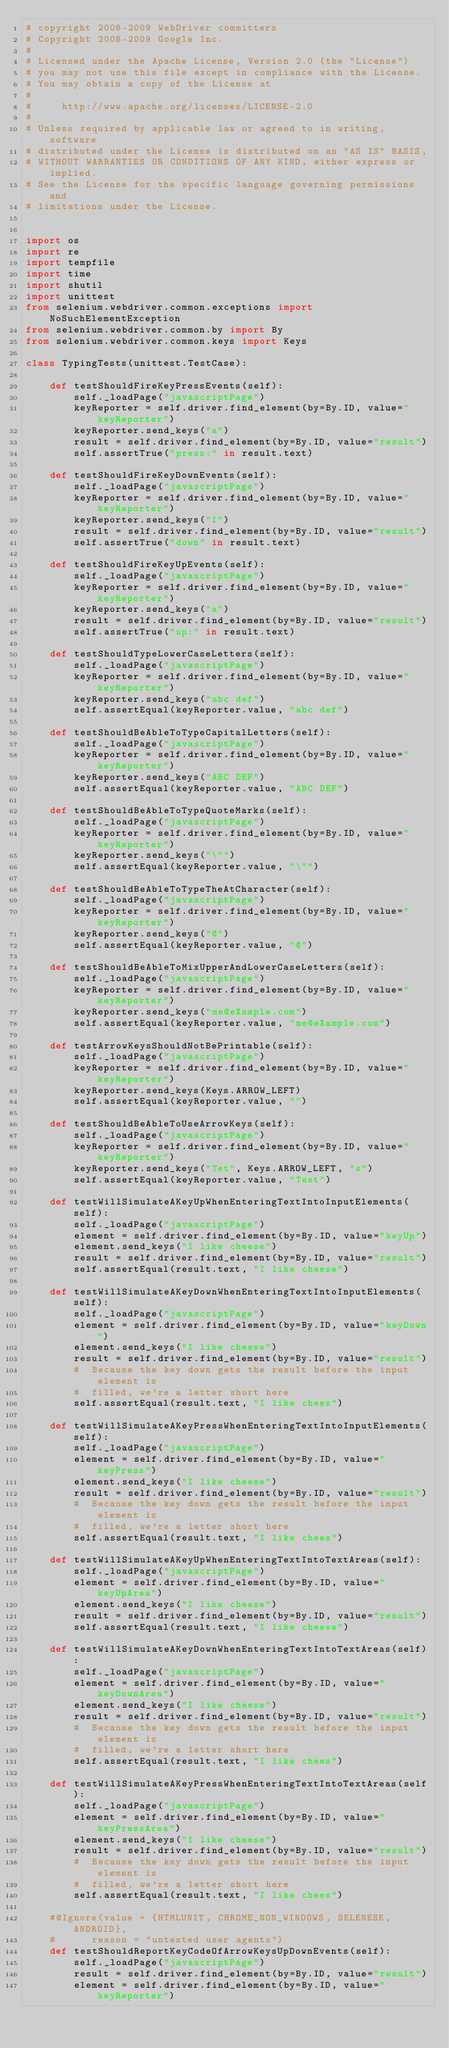<code> <loc_0><loc_0><loc_500><loc_500><_Python_># copyright 2008-2009 WebDriver committers
# Copyright 2008-2009 Google Inc.
#
# Licensed under the Apache License, Version 2.0 (the "License")
# you may not use this file except in compliance with the License.
# You may obtain a copy of the License at
#
#     http://www.apache.org/licenses/LICENSE-2.0
#
# Unless required by applicable law or agreed to in writing, software
# distributed under the License is distributed on an "AS IS" BASIS,
# WITHOUT WARRANTIES OR CONDITIONS OF ANY KIND, either express or implied.
# See the License for the specific language governing permissions and
# limitations under the License.


import os
import re
import tempfile
import time
import shutil
import unittest
from selenium.webdriver.common.exceptions import NoSuchElementException
from selenium.webdriver.common.by import By
from selenium.webdriver.common.keys import Keys

class TypingTests(unittest.TestCase):
  
    def testShouldFireKeyPressEvents(self):
        self._loadPage("javascriptPage")
        keyReporter = self.driver.find_element(by=By.ID, value="keyReporter")
        keyReporter.send_keys("a")
        result = self.driver.find_element(by=By.ID, value="result")
        self.assertTrue("press:" in result.text)

    def testShouldFireKeyDownEvents(self):
        self._loadPage("javascriptPage")
        keyReporter = self.driver.find_element(by=By.ID, value="keyReporter")
        keyReporter.send_keys("I")
        result = self.driver.find_element(by=By.ID, value="result")
        self.assertTrue("down" in result.text)

    def testShouldFireKeyUpEvents(self):
        self._loadPage("javascriptPage")
        keyReporter = self.driver.find_element(by=By.ID, value="keyReporter")
        keyReporter.send_keys("a")
        result = self.driver.find_element(by=By.ID, value="result")
        self.assertTrue("up:" in result.text)

    def testShouldTypeLowerCaseLetters(self):
        self._loadPage("javascriptPage")
        keyReporter = self.driver.find_element(by=By.ID, value="keyReporter")
        keyReporter.send_keys("abc def")
        self.assertEqual(keyReporter.value, "abc def")
    
    def testShouldBeAbleToTypeCapitalLetters(self):
        self._loadPage("javascriptPage")
        keyReporter = self.driver.find_element(by=By.ID, value="keyReporter")
        keyReporter.send_keys("ABC DEF")
        self.assertEqual(keyReporter.value, "ABC DEF")
    
    def testShouldBeAbleToTypeQuoteMarks(self):
        self._loadPage("javascriptPage")
        keyReporter = self.driver.find_element(by=By.ID, value="keyReporter")
        keyReporter.send_keys("\"")
        self.assertEqual(keyReporter.value, "\"")
    
    def testShouldBeAbleToTypeTheAtCharacter(self):
        self._loadPage("javascriptPage")
        keyReporter = self.driver.find_element(by=By.ID, value="keyReporter")
        keyReporter.send_keys("@")
        self.assertEqual(keyReporter.value, "@")
    
    def testShouldBeAbleToMixUpperAndLowerCaseLetters(self):
        self._loadPage("javascriptPage")
        keyReporter = self.driver.find_element(by=By.ID, value="keyReporter")
        keyReporter.send_keys("me@eXample.com")
        self.assertEqual(keyReporter.value, "me@eXample.com")

    def testArrowKeysShouldNotBePrintable(self):
        self._loadPage("javascriptPage")
        keyReporter = self.driver.find_element(by=By.ID, value="keyReporter")
        keyReporter.send_keys(Keys.ARROW_LEFT)
        self.assertEqual(keyReporter.value, "")

    def testShouldBeAbleToUseArrowKeys(self):
        self._loadPage("javascriptPage")
        keyReporter = self.driver.find_element(by=By.ID, value="keyReporter")
        keyReporter.send_keys("Tet", Keys.ARROW_LEFT, "s")
        self.assertEqual(keyReporter.value, "Test")

    def testWillSimulateAKeyUpWhenEnteringTextIntoInputElements(self):
        self._loadPage("javascriptPage")
        element = self.driver.find_element(by=By.ID, value="keyUp")
        element.send_keys("I like cheese")
        result = self.driver.find_element(by=By.ID, value="result")
        self.assertEqual(result.text, "I like cheese")

    def testWillSimulateAKeyDownWhenEnteringTextIntoInputElements(self):
        self._loadPage("javascriptPage")
        element = self.driver.find_element(by=By.ID, value="keyDown")
        element.send_keys("I like cheese")
        result = self.driver.find_element(by=By.ID, value="result")
        #  Because the key down gets the result before the input element is
        #  filled, we're a letter short here
        self.assertEqual(result.text, "I like chees")

    def testWillSimulateAKeyPressWhenEnteringTextIntoInputElements(self):
        self._loadPage("javascriptPage")
        element = self.driver.find_element(by=By.ID, value="keyPress")
        element.send_keys("I like cheese")
        result = self.driver.find_element(by=By.ID, value="result")
        #  Because the key down gets the result before the input element is
        #  filled, we're a letter short here
        self.assertEqual(result.text, "I like chees")

    def testWillSimulateAKeyUpWhenEnteringTextIntoTextAreas(self):
        self._loadPage("javascriptPage")
        element = self.driver.find_element(by=By.ID, value="keyUpArea")
        element.send_keys("I like cheese")
        result = self.driver.find_element(by=By.ID, value="result")
        self.assertEqual(result.text, "I like cheese")

    def testWillSimulateAKeyDownWhenEnteringTextIntoTextAreas(self):
        self._loadPage("javascriptPage")
        element = self.driver.find_element(by=By.ID, value="keyDownArea")
        element.send_keys("I like cheese")
        result = self.driver.find_element(by=By.ID, value="result")
        #  Because the key down gets the result before the input element is
        #  filled, we're a letter short here
        self.assertEqual(result.text, "I like chees")

    def testWillSimulateAKeyPressWhenEnteringTextIntoTextAreas(self):
        self._loadPage("javascriptPage")
        element = self.driver.find_element(by=By.ID, value="keyPressArea")
        element.send_keys("I like cheese")
        result = self.driver.find_element(by=By.ID, value="result")
        #  Because the key down gets the result before the input element is
        #  filled, we're a letter short here
        self.assertEqual(result.text, "I like chees")

    #@Ignore(value = {HTMLUNIT, CHROME_NON_WINDOWS, SELENESE, ANDROID},
    #      reason = "untested user agents")
    def testShouldReportKeyCodeOfArrowKeysUpDownEvents(self):
        self._loadPage("javascriptPage")
        result = self.driver.find_element(by=By.ID, value="result")
        element = self.driver.find_element(by=By.ID, value="keyReporter")</code> 